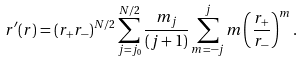Convert formula to latex. <formula><loc_0><loc_0><loc_500><loc_500>r ^ { \prime } ( r ) = ( r _ { + } r _ { - } ) ^ { N / 2 } \sum _ { j = j _ { 0 } } ^ { N / 2 } \frac { m _ { j } } { ( j + 1 ) } \sum _ { m = - j } ^ { j } m \left ( \frac { r _ { + } } { r _ { - } } \right ) ^ { m } .</formula> 